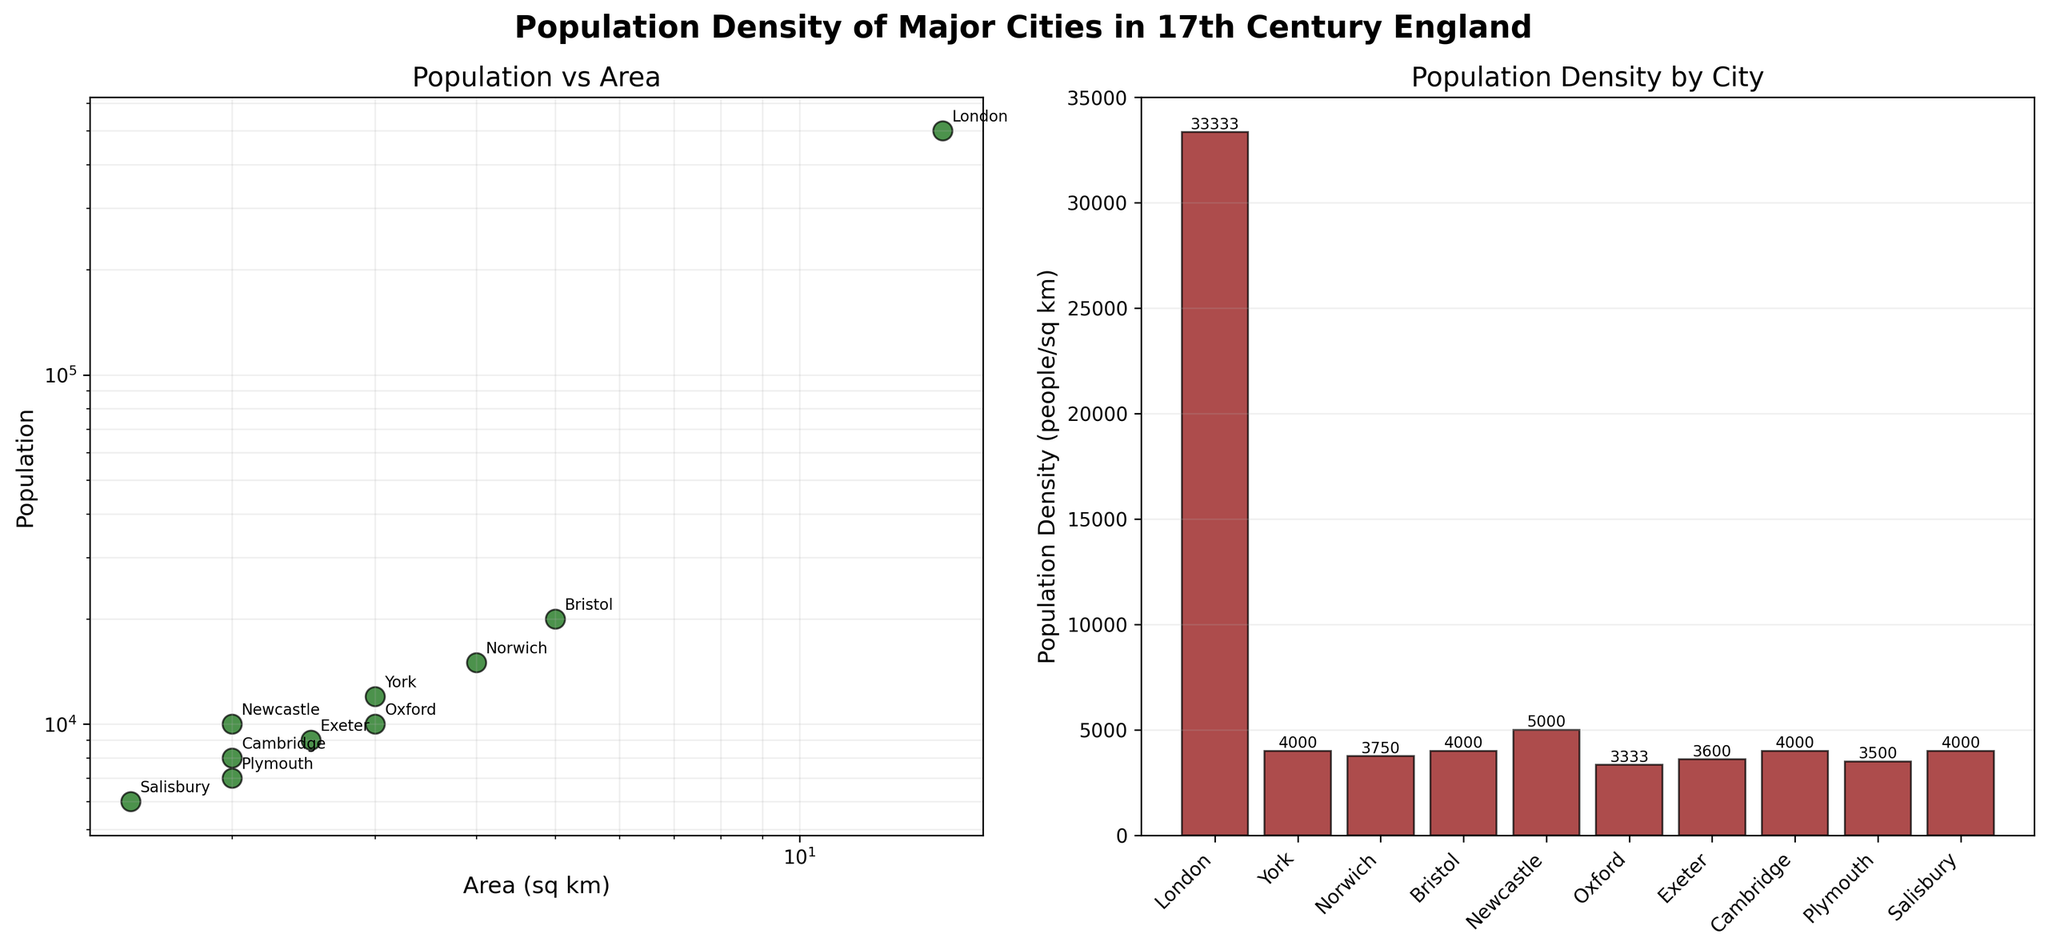What is the title of the figure? The title is located at the top center of the figure.
Answer: Population Density of Major Cities in 17th Century England What is the scale of the axes in the first subplot? The scales of the axes are indicated by the logarithmic nature of the ticks along both the x and y axes.
Answer: Logarithmic Which city had the highest population in the first subplot? The highest point on the y-axis of the first subplot (Population vs. Area) represents the city with the highest population.
Answer: London What is the population density of Oxford? Population density is calculated by dividing the population by the area. For Oxford, it’s 10000 (Population) / 3 (Area).
Answer: 3333.33 people/sq km Compare the population density of Norwich and Plymouth. Which one is higher? The respective population densities can be calculated and compared: Norwich (15000/4 = 3750), Plymouth (7000/2 = 3500).
Answer: Norwich Which city has the smallest area, and what is its population density? Identify the city with the smallest value along the x-axis in the first subplot and calculate its population density. Salisbury has the smallest area (1.5 sq km), and its population density is 6000 / 1.5.
Answer: Salisbury, 4000 people/sq km What trend do you observe in the relationship between population and area? Describe the overall pattern seen in the first subplot. There is a roughly linear trend in a log-log scale, indicating a power-law relationship between population and area.
Answer: Power-law relationship How many cities have a population density greater than 5000 people per sq km? Calculate the population density for each city and count those exceeding 5000. These are London, Norwich, Salisbury.
Answer: 3 cities Which cities have an area between 2 and 4 sq km? Refer to the x-axis in the first subplot and identify cities within the specified range.
Answer: York, Norwich, Oxford, Exeter, Cambridge, Plymouth Is there any city with an area of exactly 2 sq km, and if so, what is its population? Verify the x-axis values and corresponding cities in the first subplot. Newcastle and Cambridge both have an area of 2 sq km.
Answer: Newcastle (10000), Cambridge (8000) 